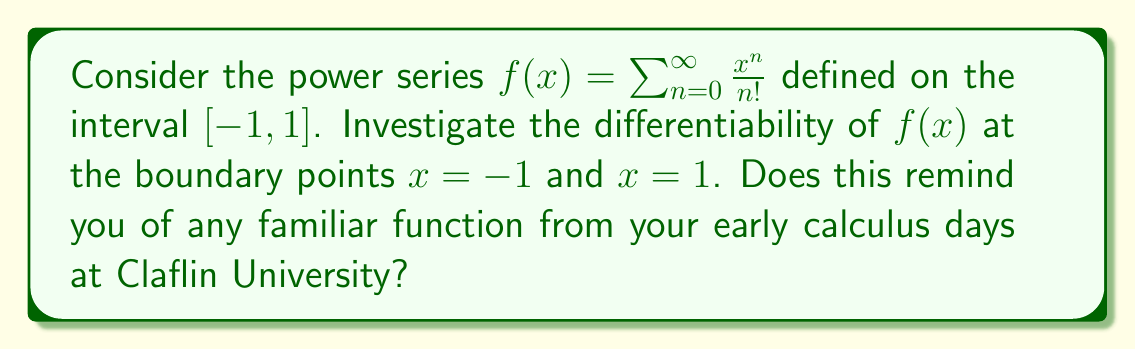Solve this math problem. Let's approach this step-by-step:

1) First, we recognize that the given power series is the Taylor series for the exponential function $e^x$ centered at $x=0$. This series converges for all real numbers, but we're specifically interested in the interval $[-1, 1]$.

2) To investigate differentiability at the boundary points, we need to check if the derivative exists at $x = -1$ and $x = 1$.

3) The derivative of a power series within its radius of convergence is obtained by term-by-term differentiation. So, the derivative of $f(x)$ is:

   $$f'(x) = \sum_{n=1}^{\infty} \frac{x^{n-1}}{(n-1)!} = \sum_{n=0}^{\infty} \frac{x^n}{n!} = f(x)$$

4) This means that $f'(x) = f(x)$ for all $x$ in $(-1, 1)$. But we need to check if this holds at the boundary points.

5) At $x = 1$:
   $$f(1) = \sum_{n=0}^{\infty} \frac{1}{n!} = e$$
   $$f'(1) = \lim_{h \to 0} \frac{f(1+h) - f(1)}{h} = \lim_{h \to 0} \frac{e^{1+h} - e}{h} = e$$

6) At $x = -1$:
   $$f(-1) = \sum_{n=0}^{\infty} \frac{(-1)^n}{n!} = \frac{1}{e}$$
   $$f'(-1) = \lim_{h \to 0} \frac{f(-1+h) - f(-1)}{h} = \lim_{h \to 0} \frac{e^{-1+h} - \frac{1}{e}}{h} = \frac{1}{e}$$

7) We see that $f'(x) = f(x)$ holds at both boundary points, confirming that $f(x)$ is differentiable at $x = -1$ and $x = 1$.

This analysis shows that the function $f(x) = e^x$ is differentiable on the entire closed interval $[-1, 1]$, maintaining its remarkable property that it is its own derivative.
Answer: The function $f(x) = \sum_{n=0}^{\infty} \frac{x^n}{n!}$ is differentiable at both boundary points $x = -1$ and $x = 1$. At these points, $f'(-1) = f(-1) = \frac{1}{e}$ and $f'(1) = f(1) = e$, respectively. 